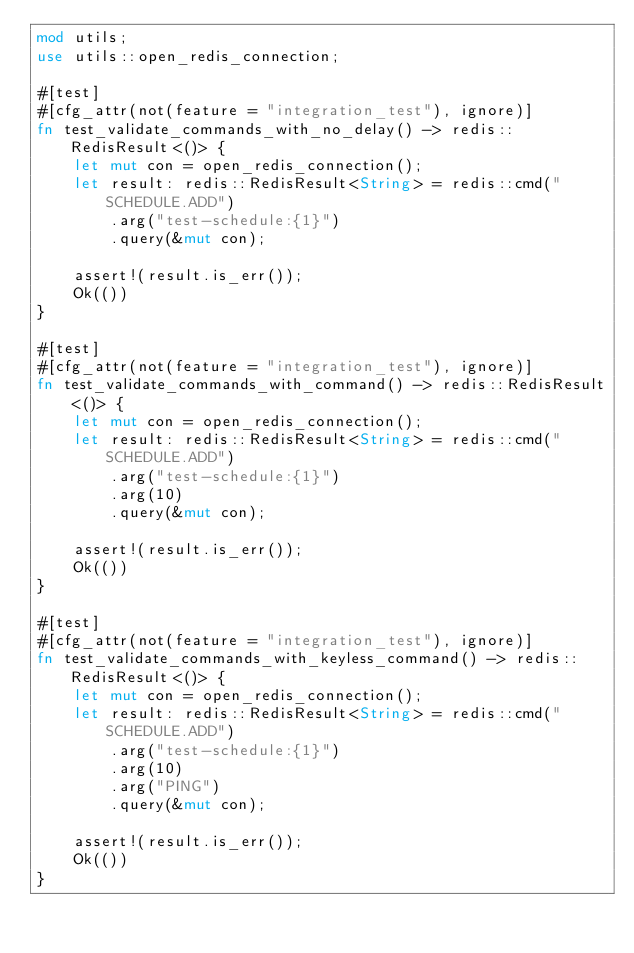<code> <loc_0><loc_0><loc_500><loc_500><_Rust_>mod utils;
use utils::open_redis_connection;

#[test]
#[cfg_attr(not(feature = "integration_test"), ignore)]
fn test_validate_commands_with_no_delay() -> redis::RedisResult<()> {
    let mut con = open_redis_connection();
    let result: redis::RedisResult<String> = redis::cmd("SCHEDULE.ADD")
        .arg("test-schedule:{1}")
        .query(&mut con);

    assert!(result.is_err());
    Ok(())
}

#[test]
#[cfg_attr(not(feature = "integration_test"), ignore)]
fn test_validate_commands_with_command() -> redis::RedisResult<()> {
    let mut con = open_redis_connection();
    let result: redis::RedisResult<String> = redis::cmd("SCHEDULE.ADD")
        .arg("test-schedule:{1}")
        .arg(10)
        .query(&mut con);

    assert!(result.is_err());
    Ok(())
}

#[test]
#[cfg_attr(not(feature = "integration_test"), ignore)]
fn test_validate_commands_with_keyless_command() -> redis::RedisResult<()> {
    let mut con = open_redis_connection();
    let result: redis::RedisResult<String> = redis::cmd("SCHEDULE.ADD")
        .arg("test-schedule:{1}")
        .arg(10)
        .arg("PING")
        .query(&mut con);

    assert!(result.is_err());
    Ok(())
}
</code> 